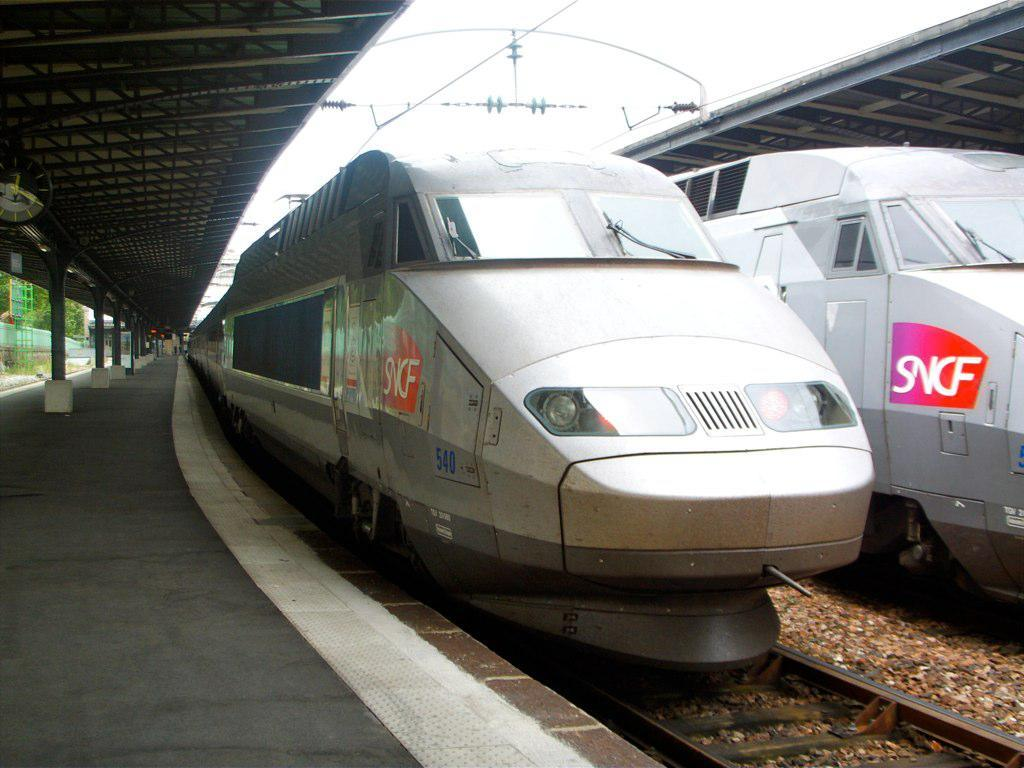<image>
Render a clear and concise summary of the photo. Two parked trains parked next to one another with a logo "SNCF". 